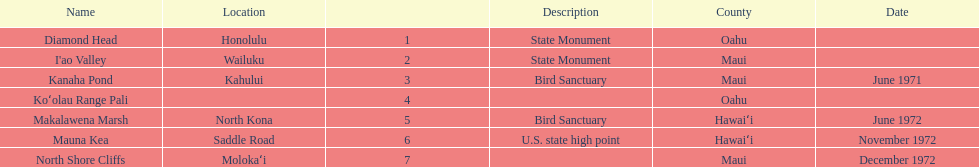Other than mauna kea, name a place in hawaii. Makalawena Marsh. 